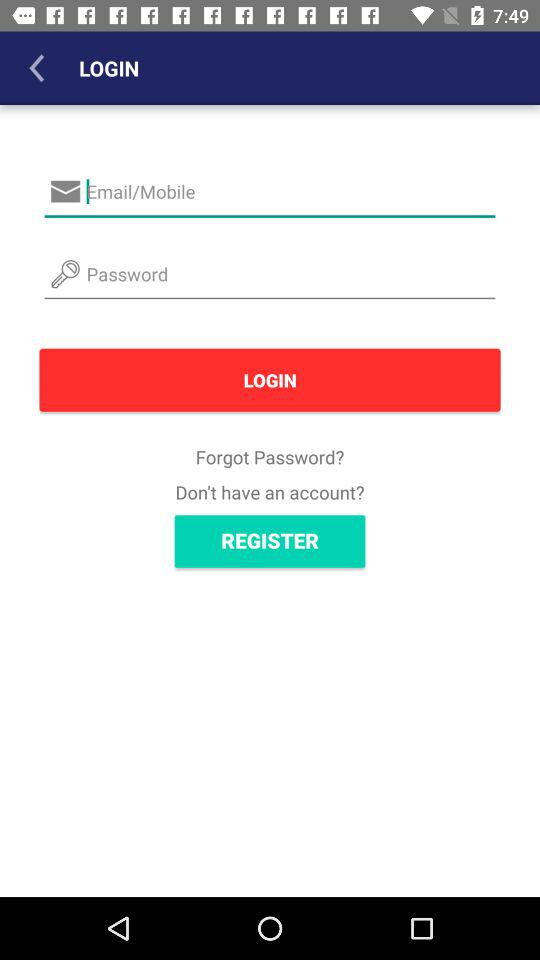How many text inputs are on the login screen?
Answer the question using a single word or phrase. 2 